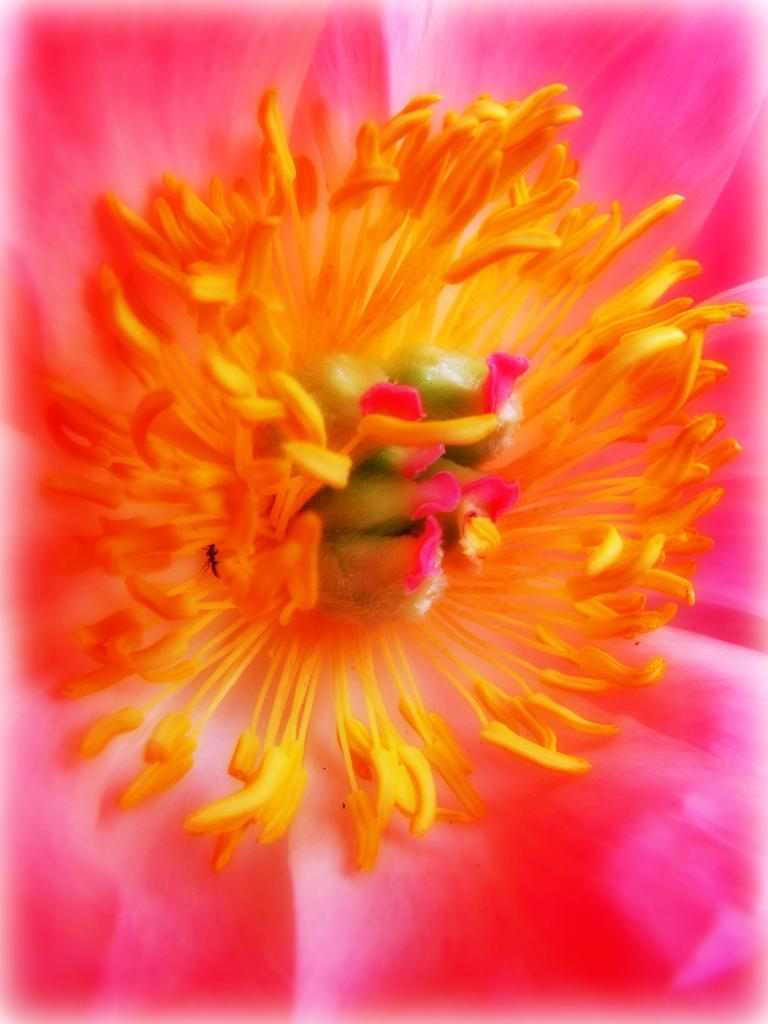What is the main subject of the image? There is a flower in the image. Can you tell me how the flower is helping the robin in the image? There is no robin present in the image, and therefore no interaction between the flower and a robin can be observed. 